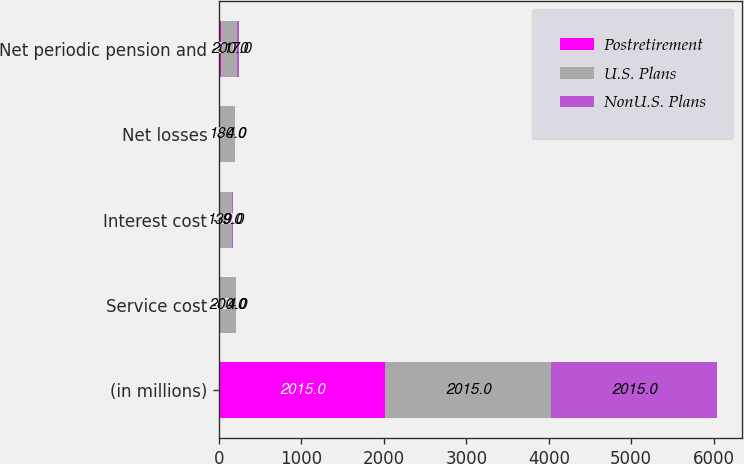Convert chart to OTSL. <chart><loc_0><loc_0><loc_500><loc_500><stacked_bar_chart><ecel><fcel>(in millions)<fcel>Service cost<fcel>Interest cost<fcel>Net losses<fcel>Net periodic pension and<nl><fcel>Postretirement<fcel>2015<fcel>5<fcel>17<fcel>14<fcel>22<nl><fcel>U.S. Plans<fcel>2015<fcel>200<fcel>139<fcel>180<fcel>200<nl><fcel>NonU.S. Plans<fcel>2015<fcel>4<fcel>9<fcel>4<fcel>17<nl></chart> 